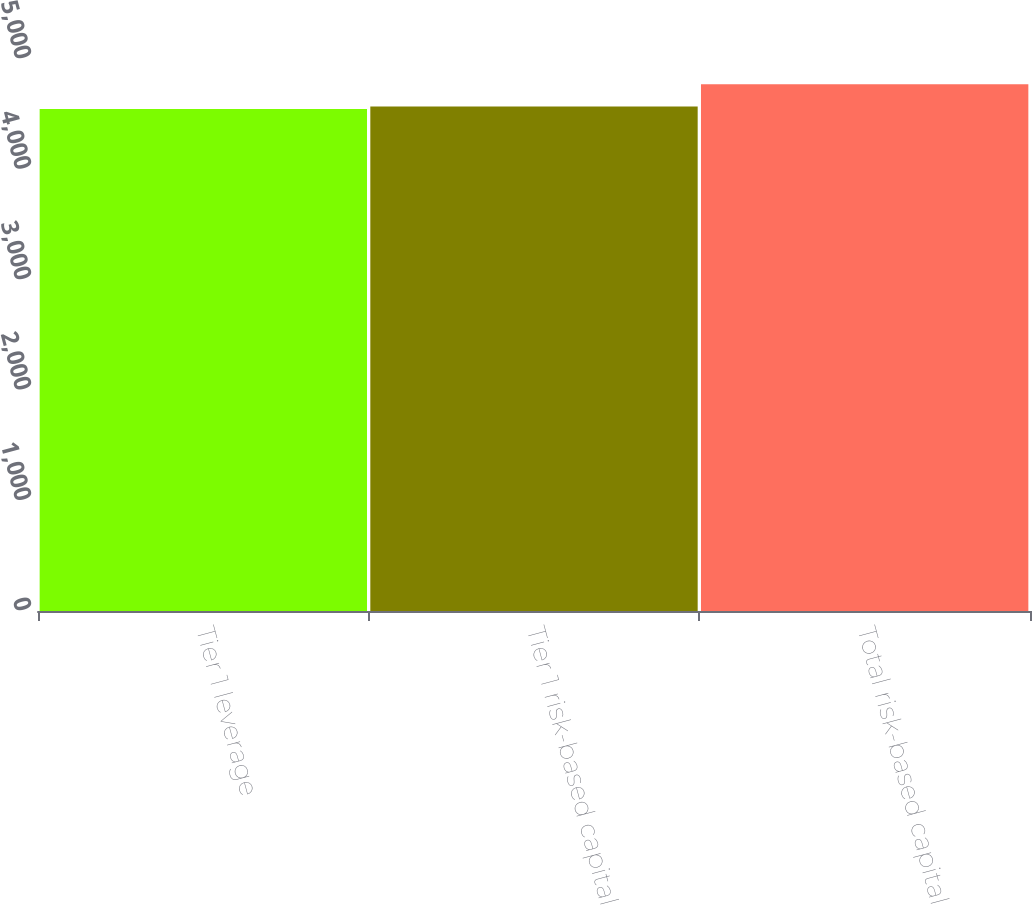Convert chart to OTSL. <chart><loc_0><loc_0><loc_500><loc_500><bar_chart><fcel>Tier 1 leverage<fcel>Tier 1 risk-based capital<fcel>Total risk-based capital<nl><fcel>4548<fcel>4570.4<fcel>4772<nl></chart> 